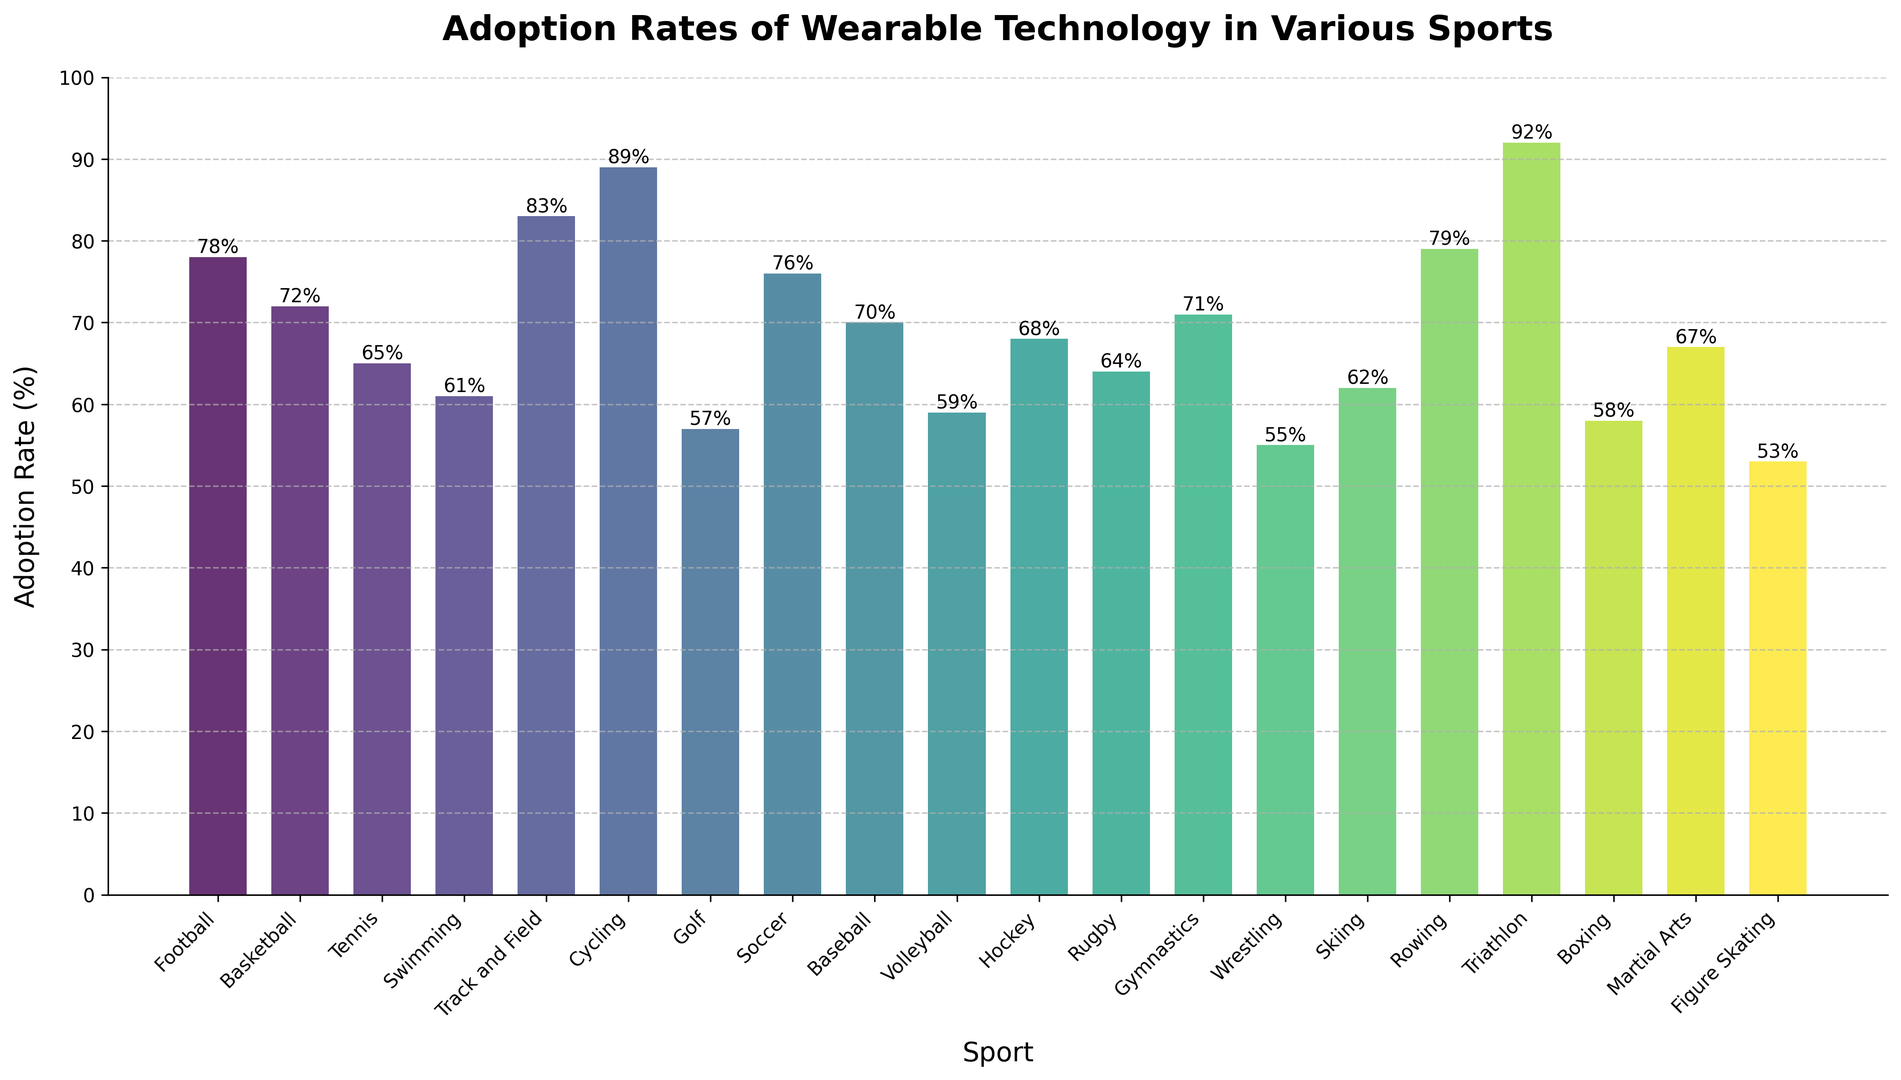Which sport has the highest adoption rate of wearable technology? The highest bar in the chart represents the sport with the highest adoption rate. Triathlon has the highest bar at 92%.
Answer: Triathlon Which sport has the lowest adoption rate of wearable technology? The shortest bar signifies the lowest adoption rate. Figure Skating has the shortest bar at 53%.
Answer: Figure Skating What is the difference in adoption rates between Cycling and Football? The adoption rate for Cycling is 89% and for Football is 78%. The difference is 89 - 78 = 11%.
Answer: 11% How many sports have an adoption rate of over 70%? Count the bars that are above the 70% mark. The sports are Football, Basketball, Track and Field, Cycling, Soccer, Baseball, Rowing, Triathlon, and Gymnastics, which sum to 9 sports.
Answer: 9 Which sports have an adoption rate less than 60%? Identify bars below the 60% mark. These sports are Golf, Volleyball, Wrestling, Boxing, and Figure Skating.
Answer: 5 Is the adoption rate of wearable technology in Martial Arts higher than in Hockey? Compare the heights of the bars for Martial Arts (67%) and Hockey (68%). Martial Arts is slightly lower.
Answer: No What is the combined adoption rate for the top 3 sports with the highest adoption rates? The top 3 sports are Triathlon (92%), Cycling (89%), and Track and Field (83%). Summing these rates gives 92 + 89 + 83 = 264%.
Answer: 264% What is the average adoption rate of the sports listed in the chart? Sum all the adoption rates and divide by the number of sports. Sum of adoption rates = 78+72+65+61+83+89+57+76+70+59+68+64+71+55+62+79+92+58+67+53 = 1270. There are 20 sports, so 1270 / 20 = 63.5%.
Answer: 63.5% Which sports have an adoption rate exactly equal to 64%? Find the sport that corresponds to the 64% bar. Rugby has an adoption rate of 64%.
Answer: Rugby What’s the median adoption rate of the sports? To find the median, list all adoption rates in ascending order and find the middle value. Rates in order: 53, 55, 57, 58, 59, 61, 62, 64, 65, 67, 68, 70, 71, 72, 76, 78, 79, 83, 89, 92. The median values (10th and 11th positions) are 67 and 68, so the median is (67 + 68) / 2 = 67.5%.
Answer: 67.5% 